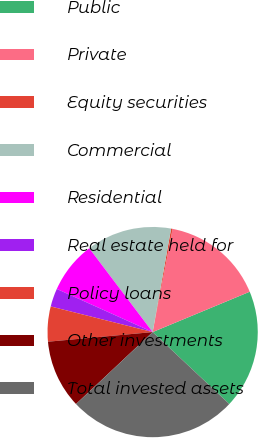<chart> <loc_0><loc_0><loc_500><loc_500><pie_chart><fcel>Public<fcel>Private<fcel>Equity securities<fcel>Commercial<fcel>Residential<fcel>Real estate held for<fcel>Policy loans<fcel>Other investments<fcel>Total invested assets<nl><fcel>18.27%<fcel>15.69%<fcel>0.23%<fcel>13.12%<fcel>7.96%<fcel>2.81%<fcel>5.38%<fcel>10.54%<fcel>26.0%<nl></chart> 